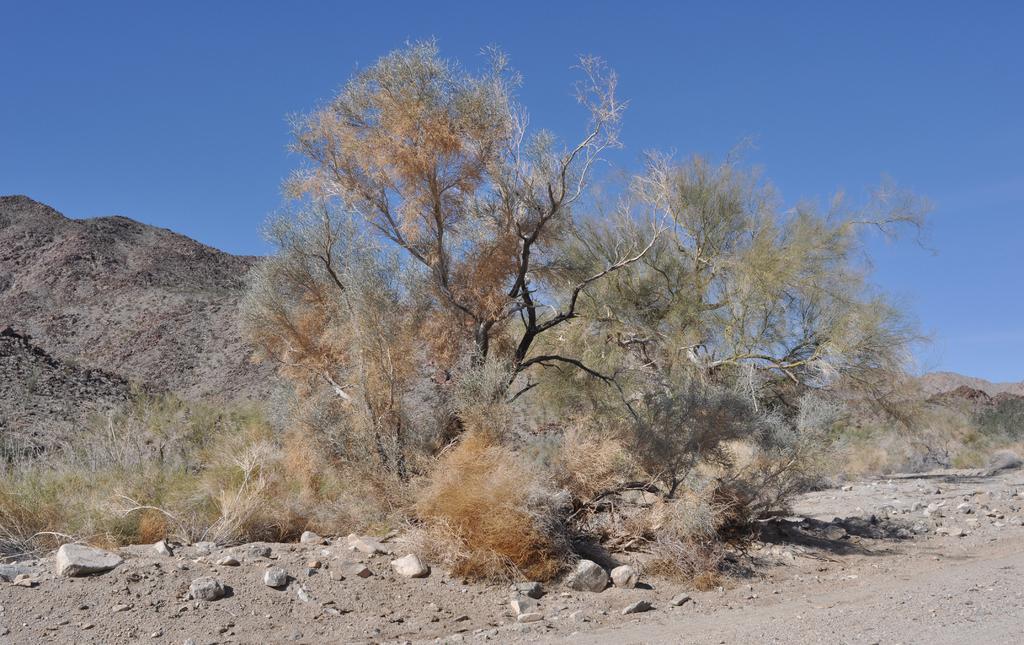How would you summarize this image in a sentence or two? In this picture we can see there are stones, trees, hills and the sky. 